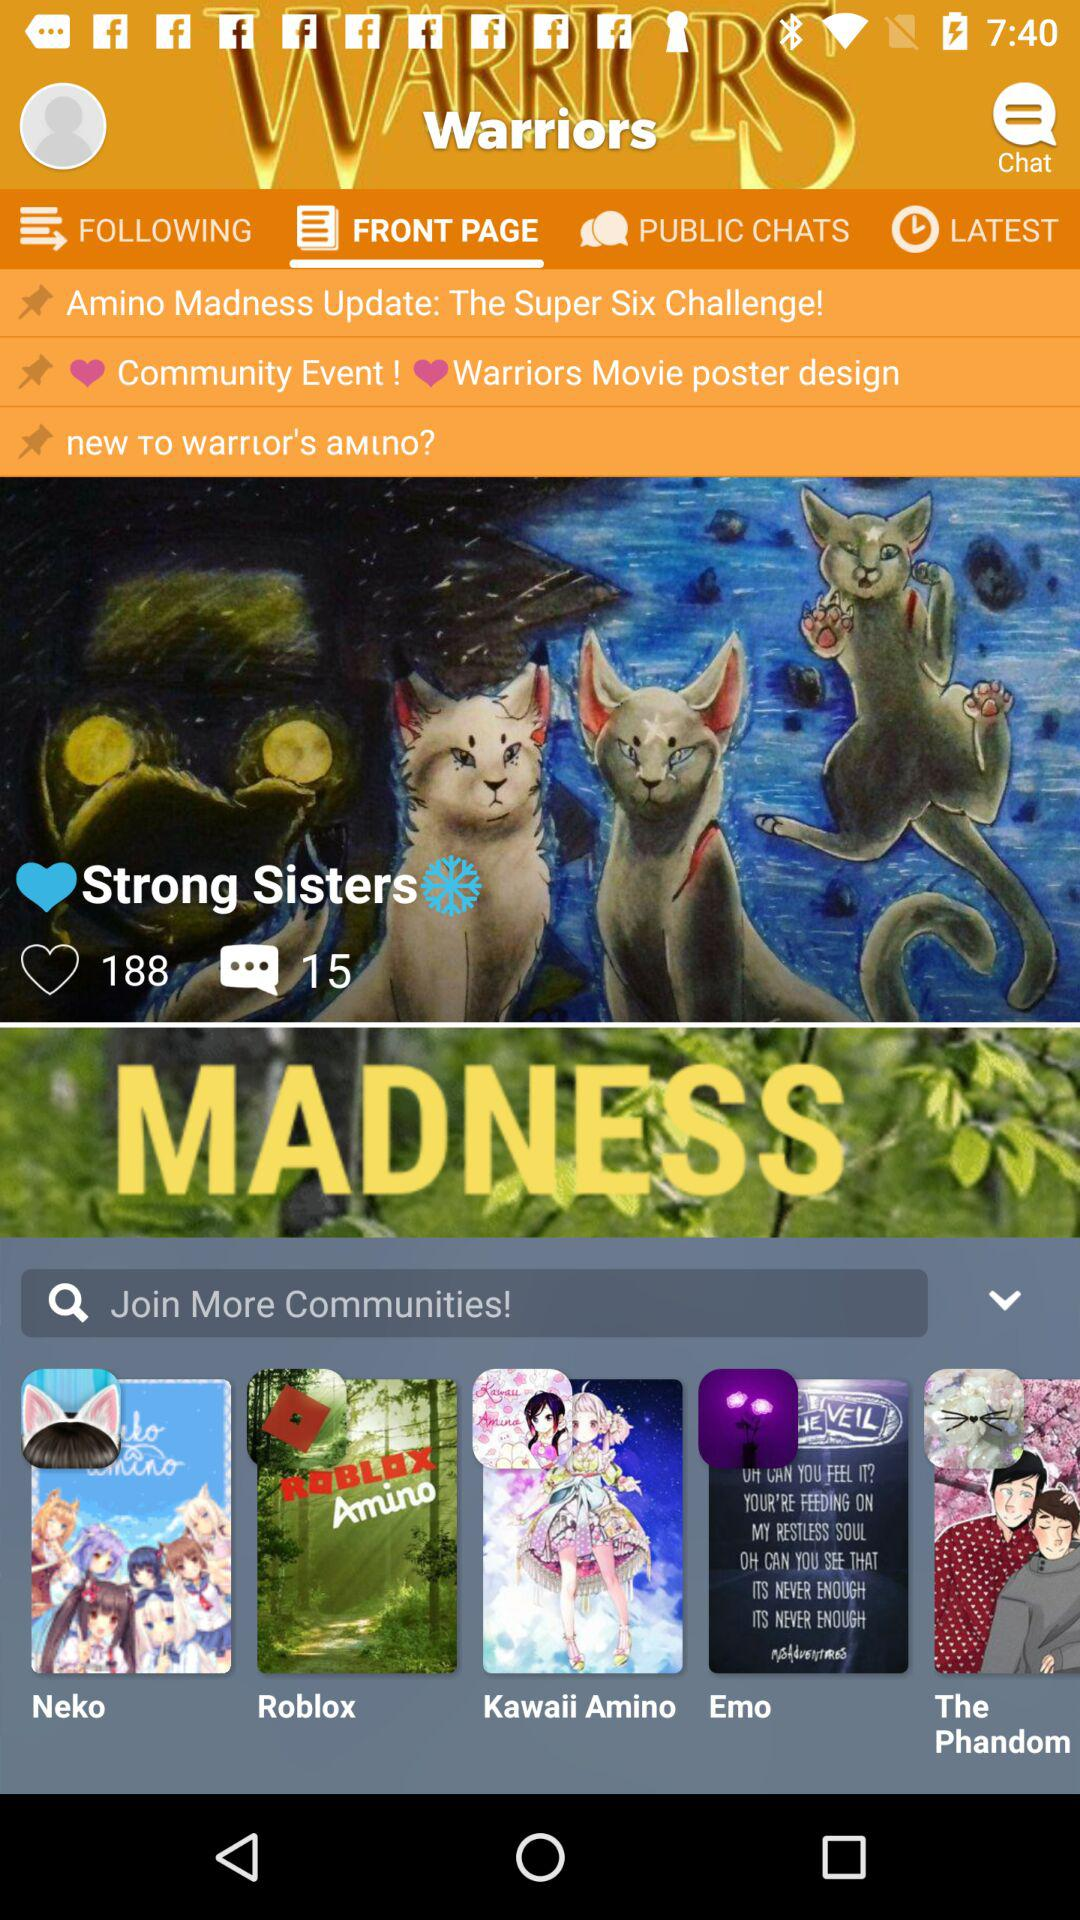How many people like "Warriors Movie poster design"?
When the provided information is insufficient, respond with <no answer>. <no answer> 